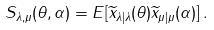<formula> <loc_0><loc_0><loc_500><loc_500>S _ { \lambda , \mu } ( \theta , \alpha ) = E [ \widetilde { x } _ { \lambda | \lambda } ( \theta ) \widetilde { x } _ { \mu | \mu } ( \alpha ) ] \, .</formula> 